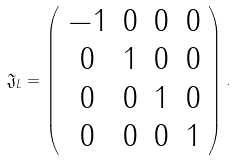Convert formula to latex. <formula><loc_0><loc_0><loc_500><loc_500>\mathfrak { J } _ { L } = \left ( \begin{array} { c c c c } - 1 & 0 & 0 & 0 \\ 0 & 1 & 0 & 0 \\ 0 & 0 & 1 & 0 \\ 0 & 0 & 0 & 1 \end{array} \right ) .</formula> 